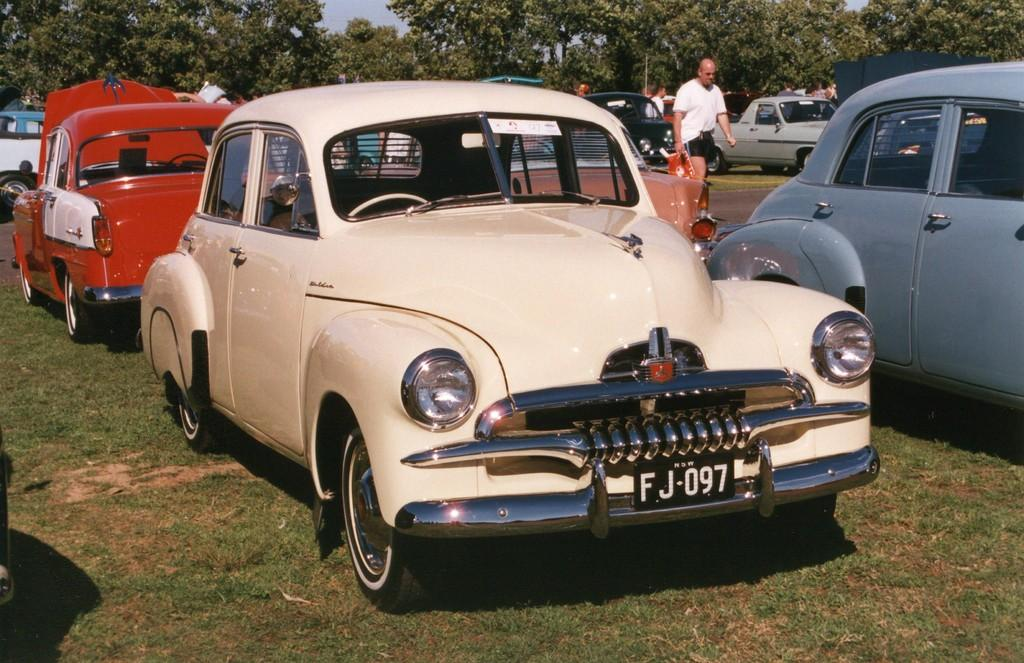What is the main subject in the center of the image? There are cars in the center of the image. What can be seen in the background of the image? There are trees in the background of the image. What type of vegetation is at the bottom of the image? There is grass at the bottom of the image. What is the person in the image doing? There is a person walking on the road. What type of hose is being used to water the pizzas in the image? There are no hoses or pizzas present in the image. What effect does the presence of the cars have on the environment in the image? The provided facts do not mention any environmental effects of the cars in the image. 